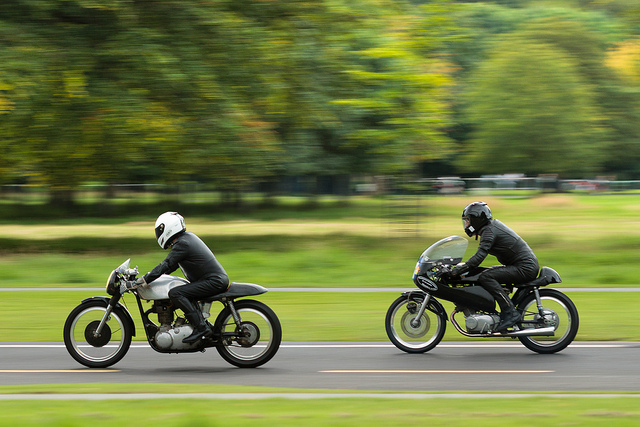How many people can you see? 2 